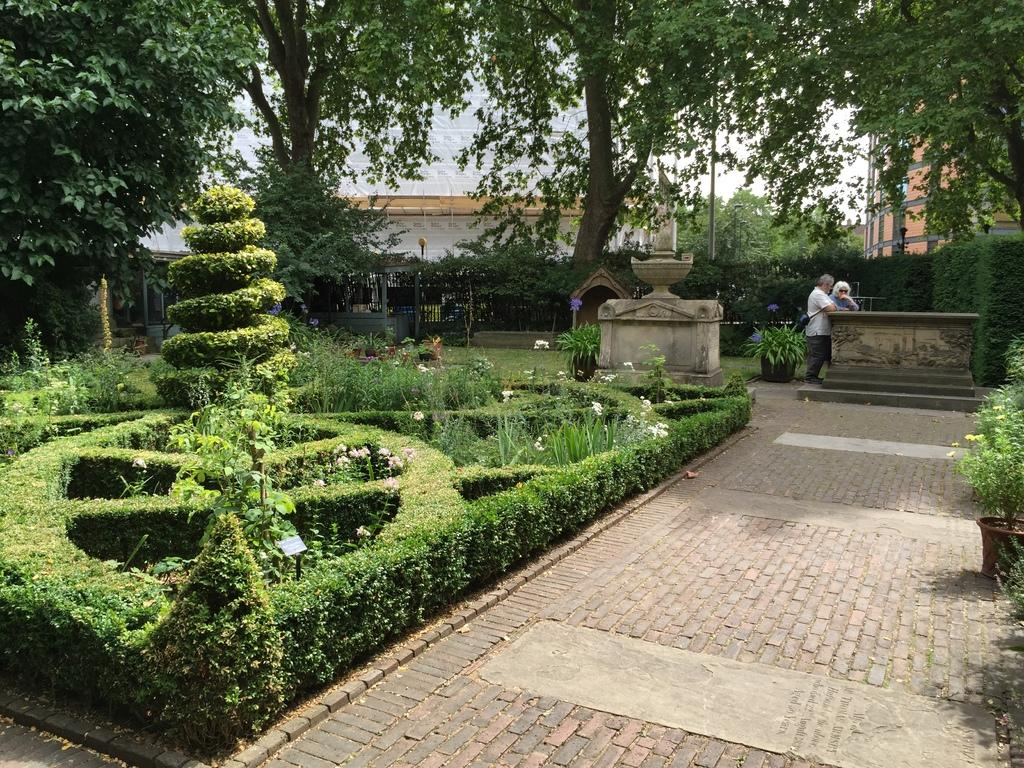What type of path is visible in the image? There is a walkway in the image. What kind of vegetation can be seen in the image? There are plants, flowers, and trees in the image. What type of containers are present in the image? There are pots in the image. How many people are visible in the image? There are two people on the right side of the image. What is visible in the background of the image? The sky is visible in the background of the image. Where is the calculator located in the image? There is no calculator present in the image. What type of prison is depicted in the image? There is no prison present in the image. 